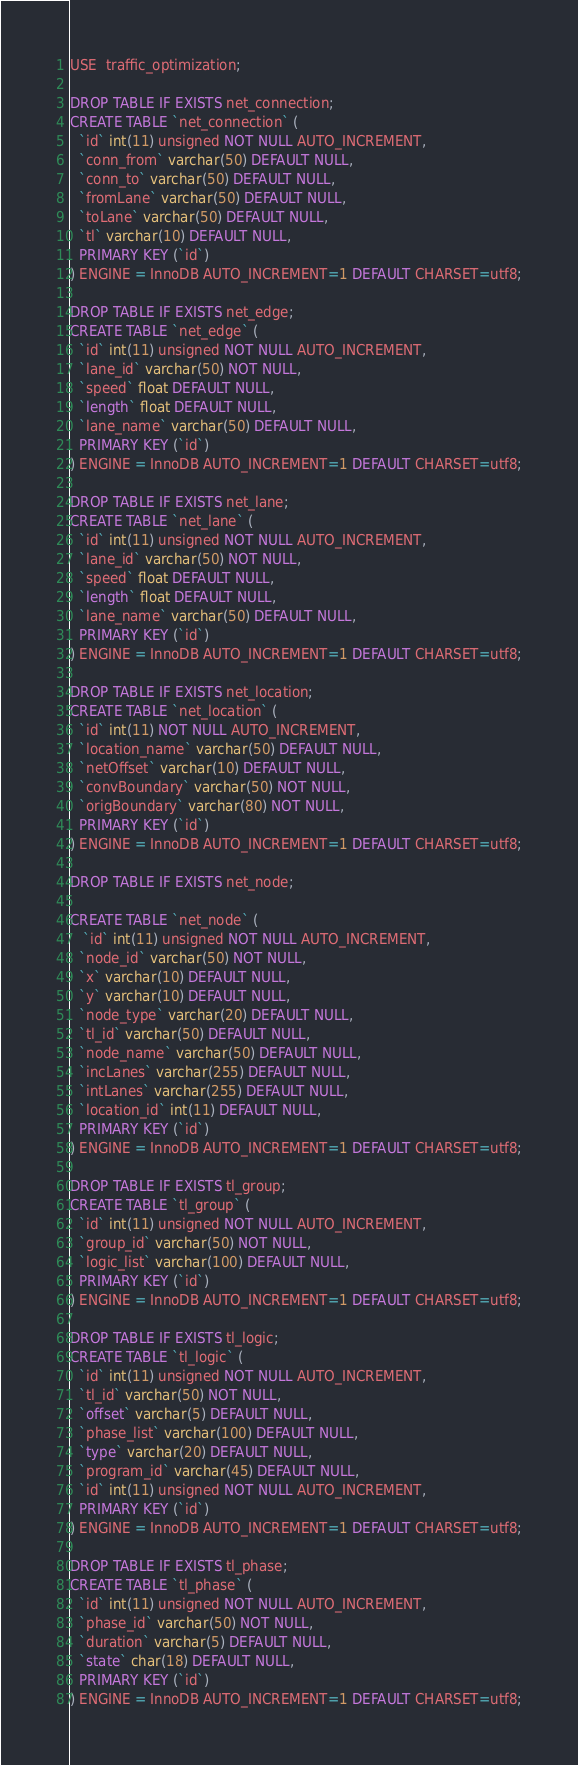<code> <loc_0><loc_0><loc_500><loc_500><_SQL_>USE  traffic_optimization;

DROP TABLE IF EXISTS net_connection;
CREATE TABLE `net_connection` (
  `id` int(11) unsigned NOT NULL AUTO_INCREMENT,
  `conn_from` varchar(50) DEFAULT NULL,
  `conn_to` varchar(50) DEFAULT NULL,
  `fromLane` varchar(50) DEFAULT NULL,
  `toLane` varchar(50) DEFAULT NULL,
  `tl` varchar(10) DEFAULT NULL,
  PRIMARY KEY (`id`)
) ENGINE = InnoDB AUTO_INCREMENT=1 DEFAULT CHARSET=utf8;

DROP TABLE IF EXISTS net_edge;
CREATE TABLE `net_edge` (
  `id` int(11) unsigned NOT NULL AUTO_INCREMENT,
  `lane_id` varchar(50) NOT NULL,
  `speed` float DEFAULT NULL,
  `length` float DEFAULT NULL,
  `lane_name` varchar(50) DEFAULT NULL,
  PRIMARY KEY (`id`)
) ENGINE = InnoDB AUTO_INCREMENT=1 DEFAULT CHARSET=utf8;

DROP TABLE IF EXISTS net_lane;
CREATE TABLE `net_lane` (
  `id` int(11) unsigned NOT NULL AUTO_INCREMENT,
  `lane_id` varchar(50) NOT NULL,
  `speed` float DEFAULT NULL,
  `length` float DEFAULT NULL,
  `lane_name` varchar(50) DEFAULT NULL,
  PRIMARY KEY (`id`)
) ENGINE = InnoDB AUTO_INCREMENT=1 DEFAULT CHARSET=utf8;

DROP TABLE IF EXISTS net_location;
CREATE TABLE `net_location` (
  `id` int(11) NOT NULL AUTO_INCREMENT,
  `location_name` varchar(50) DEFAULT NULL,
  `netOffset` varchar(10) DEFAULT NULL,
  `convBoundary` varchar(50) NOT NULL,
  `origBoundary` varchar(80) NOT NULL,
  PRIMARY KEY (`id`)
) ENGINE = InnoDB AUTO_INCREMENT=1 DEFAULT CHARSET=utf8;

DROP TABLE IF EXISTS net_node;

CREATE TABLE `net_node` (
   `id` int(11) unsigned NOT NULL AUTO_INCREMENT,
  `node_id` varchar(50) NOT NULL,
  `x` varchar(10) DEFAULT NULL,
  `y` varchar(10) DEFAULT NULL,
  `node_type` varchar(20) DEFAULT NULL,
  `tl_id` varchar(50) DEFAULT NULL,
  `node_name` varchar(50) DEFAULT NULL,
  `incLanes` varchar(255) DEFAULT NULL,
  `intLanes` varchar(255) DEFAULT NULL,
  `location_id` int(11) DEFAULT NULL,
  PRIMARY KEY (`id`)
) ENGINE = InnoDB AUTO_INCREMENT=1 DEFAULT CHARSET=utf8;

DROP TABLE IF EXISTS tl_group;
CREATE TABLE `tl_group` (
  `id` int(11) unsigned NOT NULL AUTO_INCREMENT,
  `group_id` varchar(50) NOT NULL,
  `logic_list` varchar(100) DEFAULT NULL,
  PRIMARY KEY (`id`)
) ENGINE = InnoDB AUTO_INCREMENT=1 DEFAULT CHARSET=utf8;

DROP TABLE IF EXISTS tl_logic;
CREATE TABLE `tl_logic` (
  `id` int(11) unsigned NOT NULL AUTO_INCREMENT,
  `tl_id` varchar(50) NOT NULL,
  `offset` varchar(5) DEFAULT NULL,
  `phase_list` varchar(100) DEFAULT NULL,
  `type` varchar(20) DEFAULT NULL,
  `program_id` varchar(45) DEFAULT NULL,
  `id` int(11) unsigned NOT NULL AUTO_INCREMENT,
  PRIMARY KEY (`id`)
) ENGINE = InnoDB AUTO_INCREMENT=1 DEFAULT CHARSET=utf8;

DROP TABLE IF EXISTS tl_phase;
CREATE TABLE `tl_phase` (
  `id` int(11) unsigned NOT NULL AUTO_INCREMENT,
  `phase_id` varchar(50) NOT NULL,
  `duration` varchar(5) DEFAULT NULL,
  `state` char(18) DEFAULT NULL,
  PRIMARY KEY (`id`)
) ENGINE = InnoDB AUTO_INCREMENT=1 DEFAULT CHARSET=utf8;</code> 